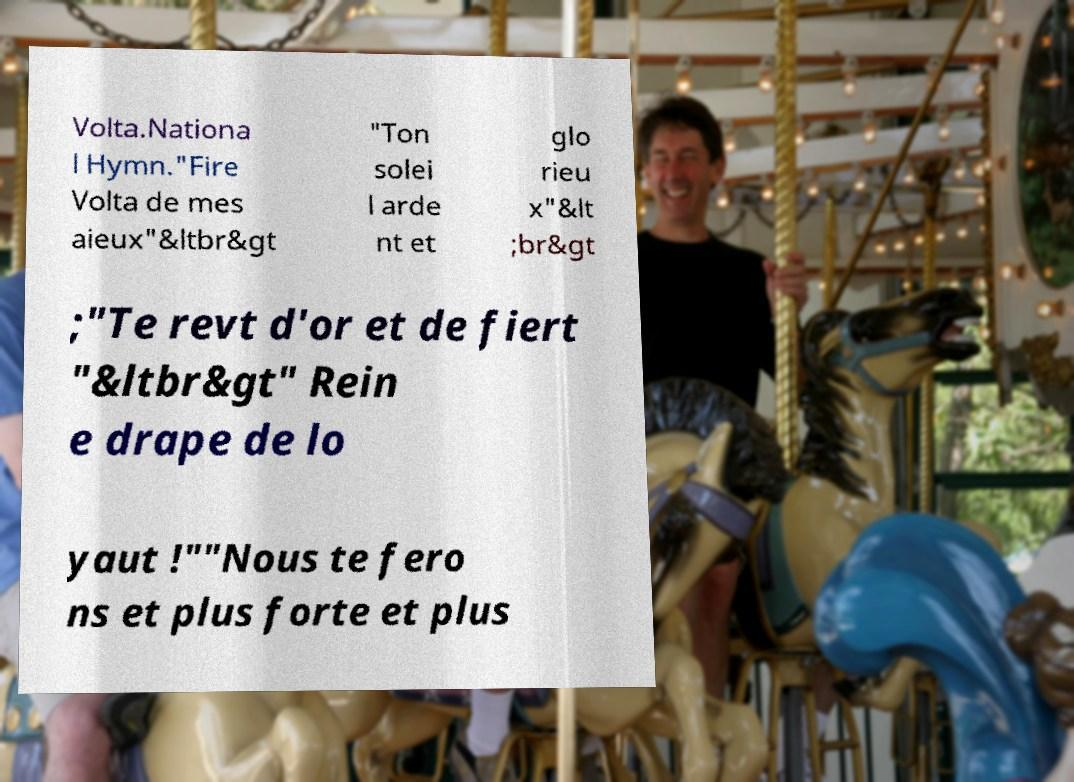Could you assist in decoding the text presented in this image and type it out clearly? Volta.Nationa l Hymn."Fire Volta de mes aieux"&ltbr&gt "Ton solei l arde nt et glo rieu x"&lt ;br&gt ;"Te revt d'or et de fiert "&ltbr&gt" Rein e drape de lo yaut !""Nous te fero ns et plus forte et plus 